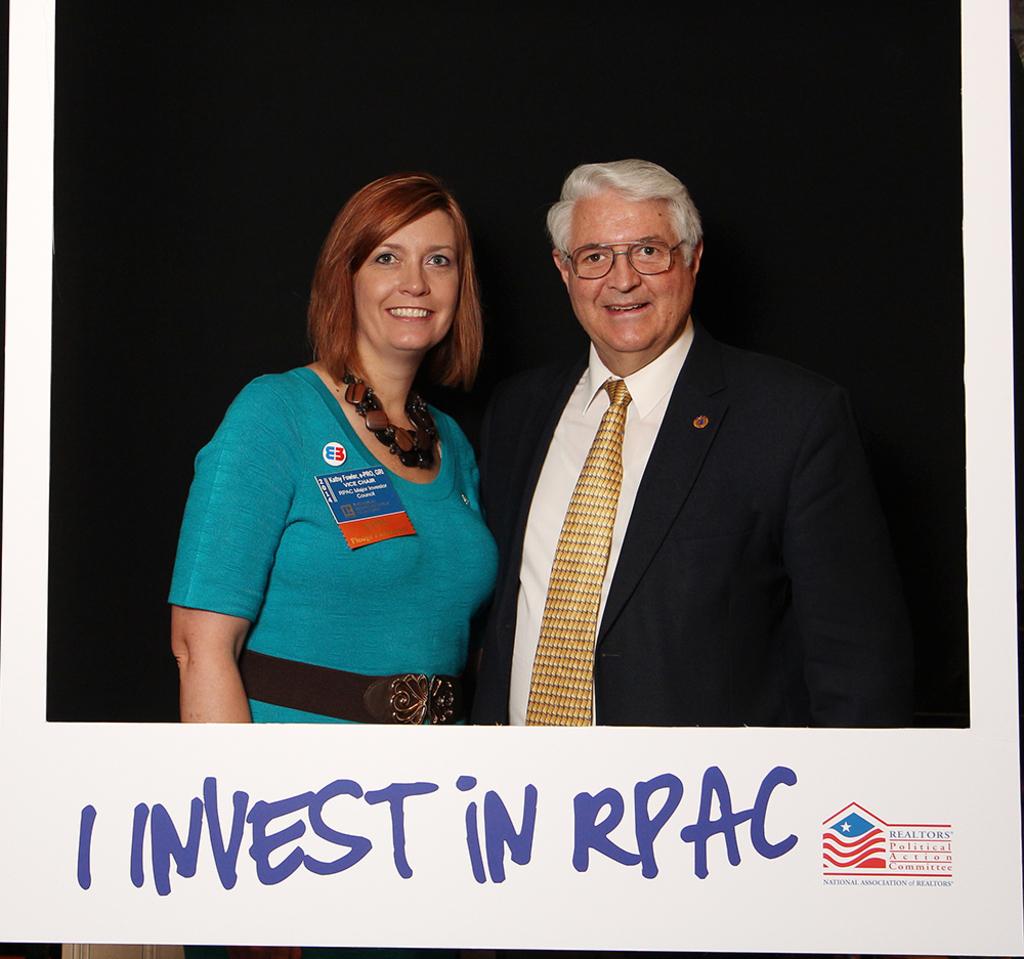What is written below the picture?
Offer a terse response. I invest in rpac. What is written to the bottom right?
Keep it short and to the point. I invest in rpac. 